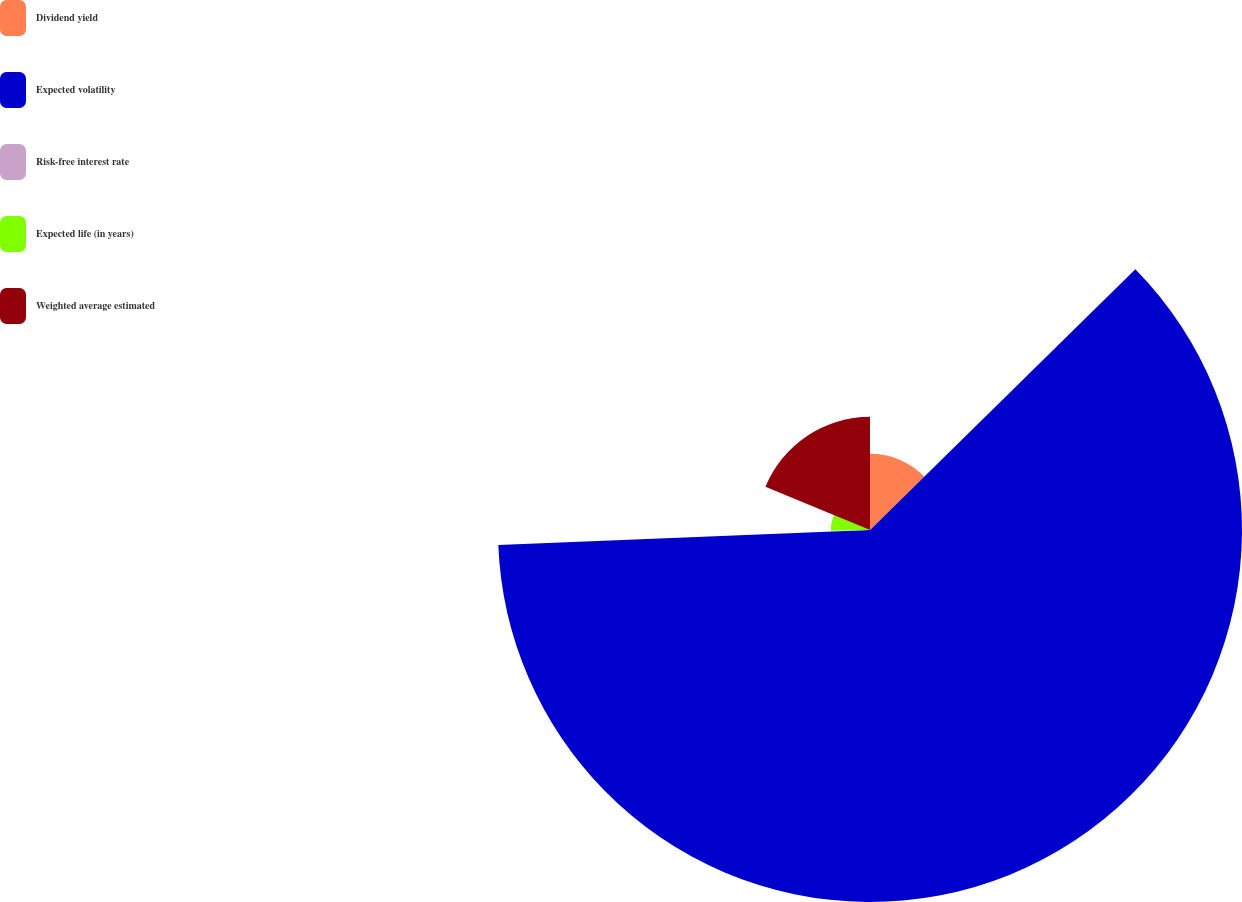<chart> <loc_0><loc_0><loc_500><loc_500><pie_chart><fcel>Dividend yield<fcel>Expected volatility<fcel>Risk-free interest rate<fcel>Expected life (in years)<fcel>Weighted average estimated<nl><fcel>12.64%<fcel>61.72%<fcel>0.37%<fcel>6.5%<fcel>18.77%<nl></chart> 